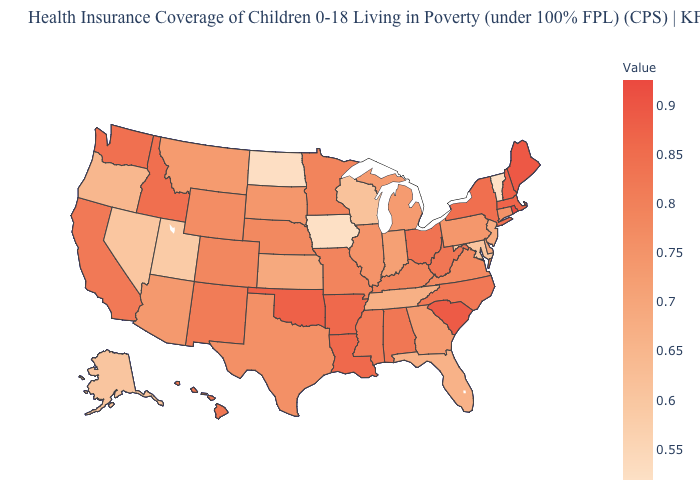Which states have the highest value in the USA?
Write a very short answer. Rhode Island. Which states have the lowest value in the West?
Concise answer only. Utah. Does Iowa have the lowest value in the MidWest?
Concise answer only. Yes. Does Louisiana have a lower value than Georgia?
Answer briefly. No. Among the states that border New Mexico , does Utah have the lowest value?
Answer briefly. Yes. Does Oklahoma have a lower value than Rhode Island?
Quick response, please. Yes. 